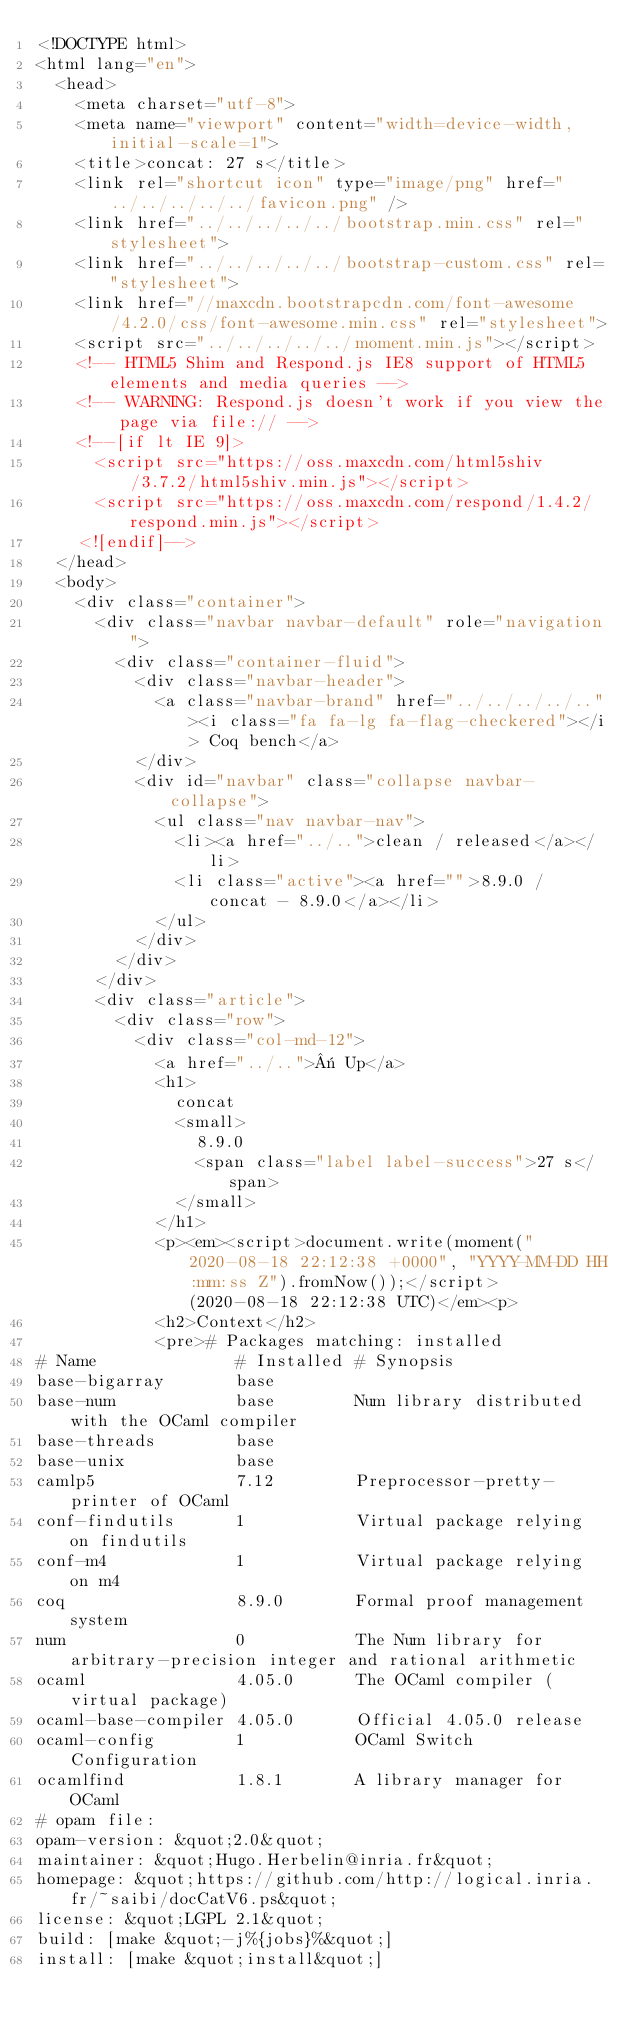Convert code to text. <code><loc_0><loc_0><loc_500><loc_500><_HTML_><!DOCTYPE html>
<html lang="en">
  <head>
    <meta charset="utf-8">
    <meta name="viewport" content="width=device-width, initial-scale=1">
    <title>concat: 27 s</title>
    <link rel="shortcut icon" type="image/png" href="../../../../../favicon.png" />
    <link href="../../../../../bootstrap.min.css" rel="stylesheet">
    <link href="../../../../../bootstrap-custom.css" rel="stylesheet">
    <link href="//maxcdn.bootstrapcdn.com/font-awesome/4.2.0/css/font-awesome.min.css" rel="stylesheet">
    <script src="../../../../../moment.min.js"></script>
    <!-- HTML5 Shim and Respond.js IE8 support of HTML5 elements and media queries -->
    <!-- WARNING: Respond.js doesn't work if you view the page via file:// -->
    <!--[if lt IE 9]>
      <script src="https://oss.maxcdn.com/html5shiv/3.7.2/html5shiv.min.js"></script>
      <script src="https://oss.maxcdn.com/respond/1.4.2/respond.min.js"></script>
    <![endif]-->
  </head>
  <body>
    <div class="container">
      <div class="navbar navbar-default" role="navigation">
        <div class="container-fluid">
          <div class="navbar-header">
            <a class="navbar-brand" href="../../../../.."><i class="fa fa-lg fa-flag-checkered"></i> Coq bench</a>
          </div>
          <div id="navbar" class="collapse navbar-collapse">
            <ul class="nav navbar-nav">
              <li><a href="../..">clean / released</a></li>
              <li class="active"><a href="">8.9.0 / concat - 8.9.0</a></li>
            </ul>
          </div>
        </div>
      </div>
      <div class="article">
        <div class="row">
          <div class="col-md-12">
            <a href="../..">« Up</a>
            <h1>
              concat
              <small>
                8.9.0
                <span class="label label-success">27 s</span>
              </small>
            </h1>
            <p><em><script>document.write(moment("2020-08-18 22:12:38 +0000", "YYYY-MM-DD HH:mm:ss Z").fromNow());</script> (2020-08-18 22:12:38 UTC)</em><p>
            <h2>Context</h2>
            <pre># Packages matching: installed
# Name              # Installed # Synopsis
base-bigarray       base
base-num            base        Num library distributed with the OCaml compiler
base-threads        base
base-unix           base
camlp5              7.12        Preprocessor-pretty-printer of OCaml
conf-findutils      1           Virtual package relying on findutils
conf-m4             1           Virtual package relying on m4
coq                 8.9.0       Formal proof management system
num                 0           The Num library for arbitrary-precision integer and rational arithmetic
ocaml               4.05.0      The OCaml compiler (virtual package)
ocaml-base-compiler 4.05.0      Official 4.05.0 release
ocaml-config        1           OCaml Switch Configuration
ocamlfind           1.8.1       A library manager for OCaml
# opam file:
opam-version: &quot;2.0&quot;
maintainer: &quot;Hugo.Herbelin@inria.fr&quot;
homepage: &quot;https://github.com/http://logical.inria.fr/~saibi/docCatV6.ps&quot;
license: &quot;LGPL 2.1&quot;
build: [make &quot;-j%{jobs}%&quot;]
install: [make &quot;install&quot;]</code> 